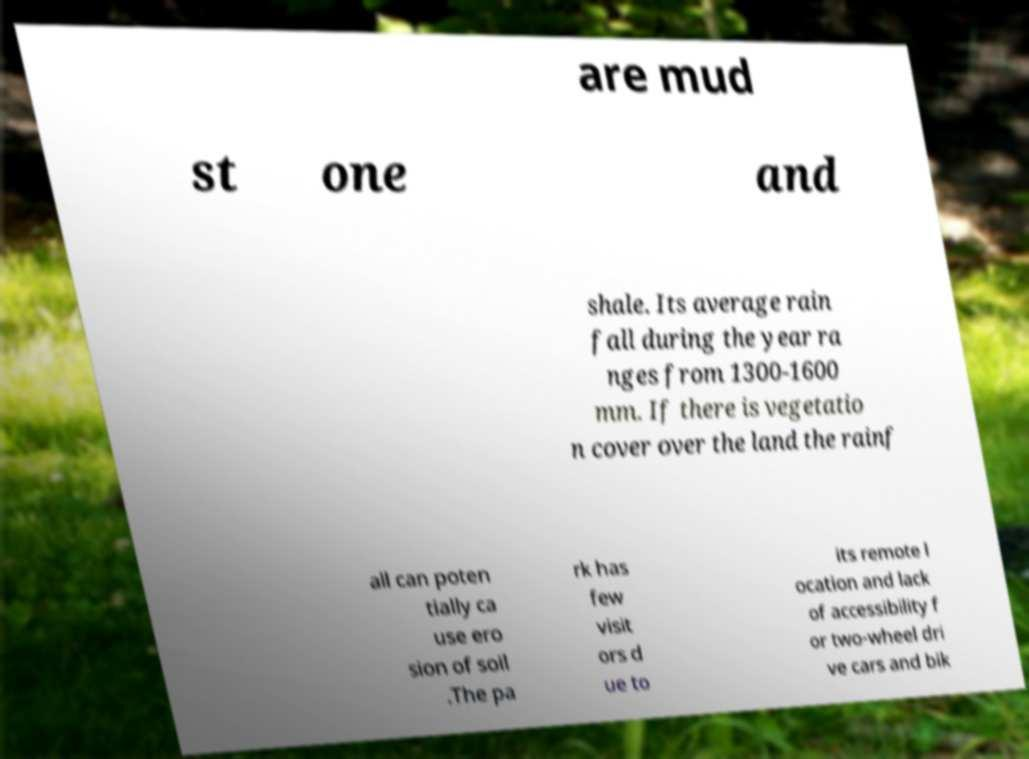What messages or text are displayed in this image? I need them in a readable, typed format. are mud st one and shale. Its average rain fall during the year ra nges from 1300-1600 mm. If there is vegetatio n cover over the land the rainf all can poten tially ca use ero sion of soil .The pa rk has few visit ors d ue to its remote l ocation and lack of accessibility f or two-wheel dri ve cars and bik 